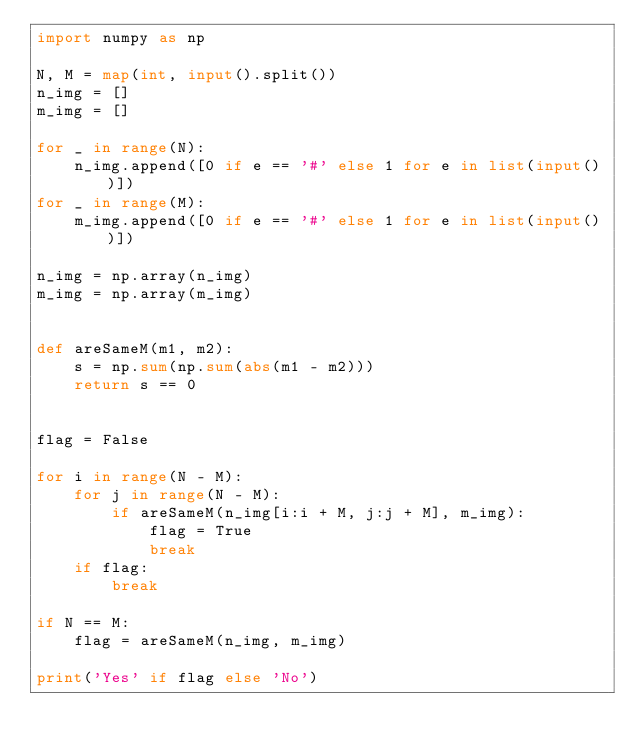<code> <loc_0><loc_0><loc_500><loc_500><_Python_>import numpy as np

N, M = map(int, input().split())
n_img = []
m_img = []

for _ in range(N):
    n_img.append([0 if e == '#' else 1 for e in list(input())])
for _ in range(M):
    m_img.append([0 if e == '#' else 1 for e in list(input())])

n_img = np.array(n_img)
m_img = np.array(m_img)


def areSameM(m1, m2):
    s = np.sum(np.sum(abs(m1 - m2)))
    return s == 0


flag = False

for i in range(N - M):
    for j in range(N - M):
        if areSameM(n_img[i:i + M, j:j + M], m_img):
            flag = True
            break
    if flag:
        break

if N == M:
    flag = areSameM(n_img, m_img)

print('Yes' if flag else 'No')
</code> 